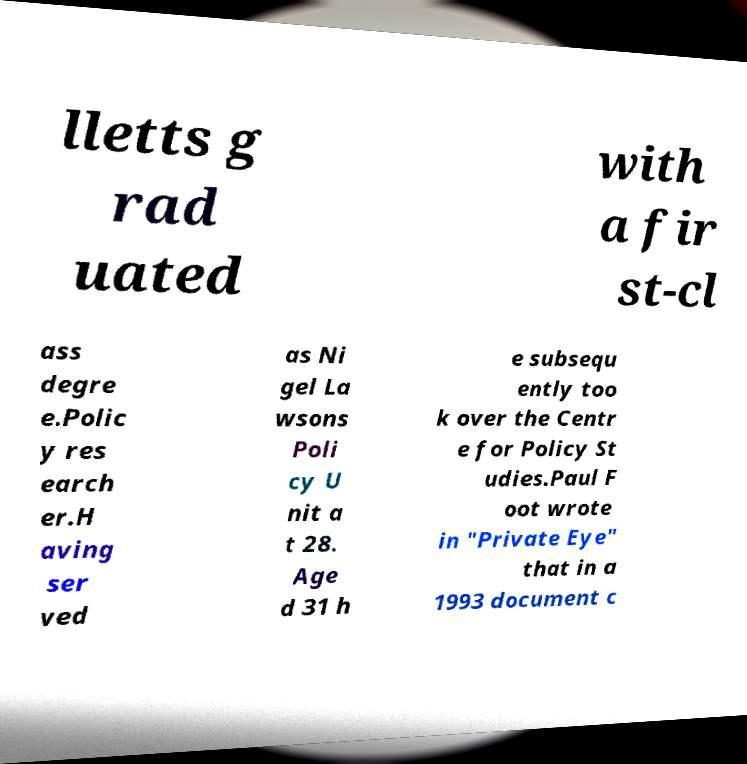Please read and relay the text visible in this image. What does it say? lletts g rad uated with a fir st-cl ass degre e.Polic y res earch er.H aving ser ved as Ni gel La wsons Poli cy U nit a t 28. Age d 31 h e subsequ ently too k over the Centr e for Policy St udies.Paul F oot wrote in "Private Eye" that in a 1993 document c 